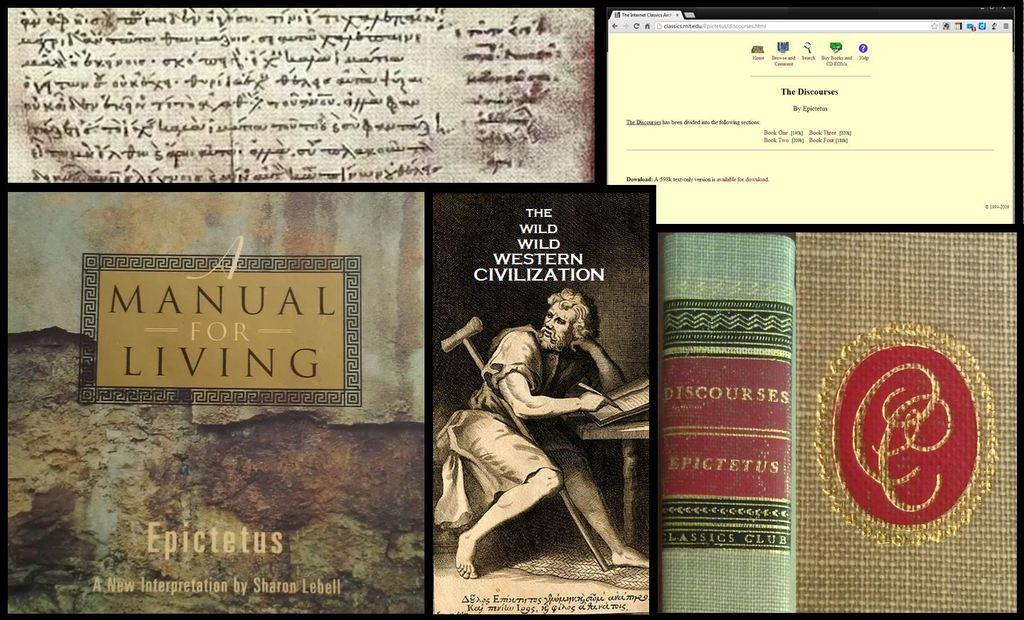What type of image is being described? The image is an edited image of a web page. What can be found on the web page? There are images of books and text on the web page. What type of hat is being offered by the snail in the image? There is no hat or snail present in the image; it consists of a web page with images of books and text. 